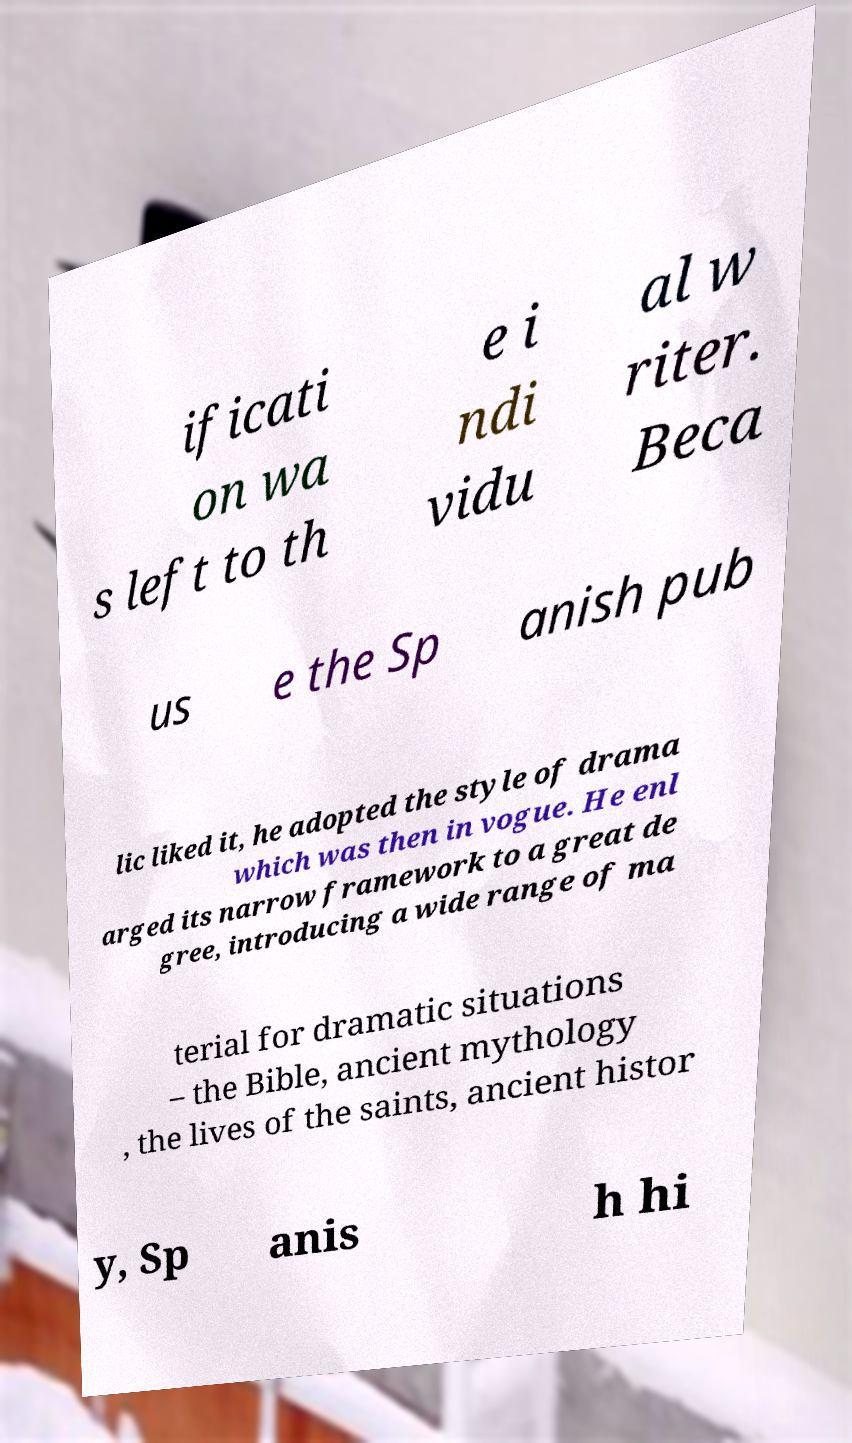Can you accurately transcribe the text from the provided image for me? ificati on wa s left to th e i ndi vidu al w riter. Beca us e the Sp anish pub lic liked it, he adopted the style of drama which was then in vogue. He enl arged its narrow framework to a great de gree, introducing a wide range of ma terial for dramatic situations – the Bible, ancient mythology , the lives of the saints, ancient histor y, Sp anis h hi 